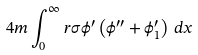<formula> <loc_0><loc_0><loc_500><loc_500>4 m \int _ { 0 } ^ { \infty } r \sigma \phi ^ { \prime } \left ( \phi ^ { \prime \prime } + \phi ^ { \prime } _ { 1 } \right ) \, d x</formula> 